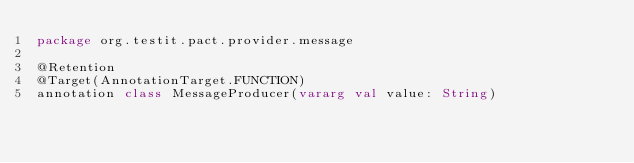Convert code to text. <code><loc_0><loc_0><loc_500><loc_500><_Kotlin_>package org.testit.pact.provider.message

@Retention
@Target(AnnotationTarget.FUNCTION)
annotation class MessageProducer(vararg val value: String)</code> 